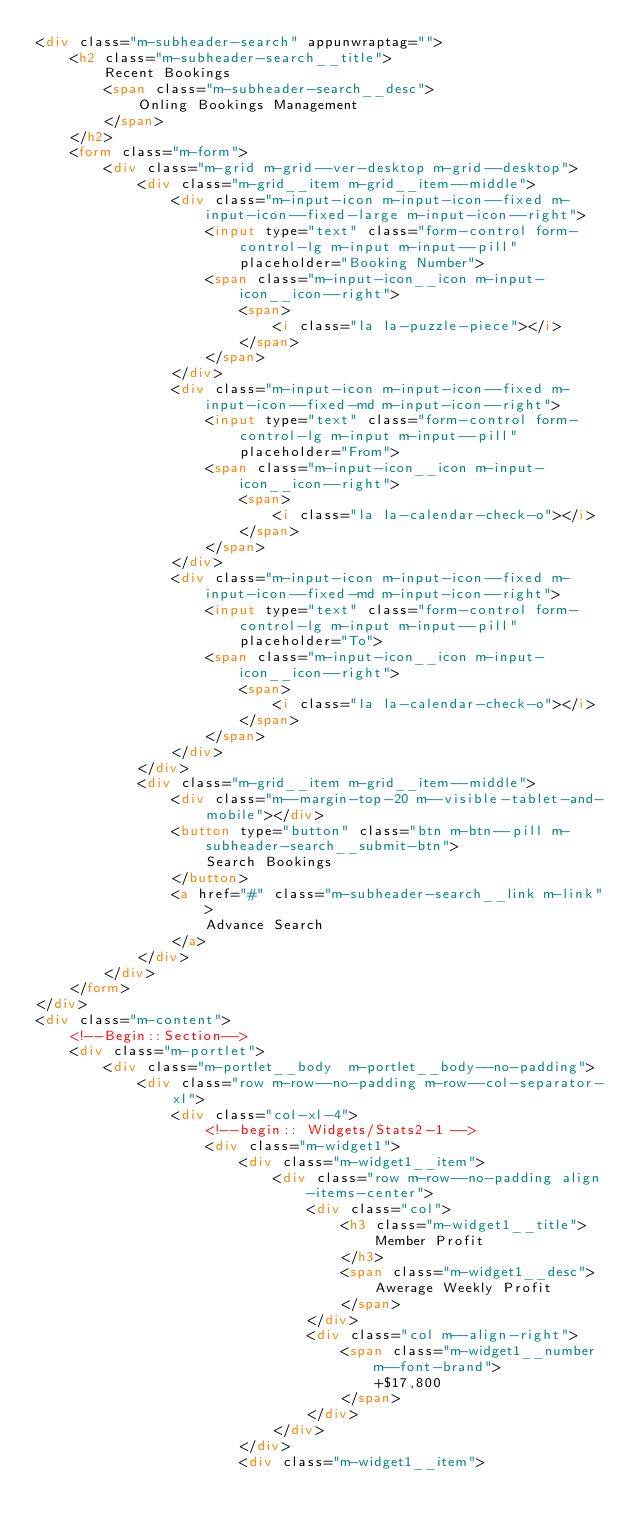Convert code to text. <code><loc_0><loc_0><loc_500><loc_500><_HTML_><div class="m-subheader-search" appunwraptag="">
	<h2 class="m-subheader-search__title">
		Recent Bookings
		<span class="m-subheader-search__desc">
			Onling Bookings Management
		</span>
	</h2>
	<form class="m-form">
		<div class="m-grid m-grid--ver-desktop m-grid--desktop">
			<div class="m-grid__item m-grid__item--middle">
				<div class="m-input-icon m-input-icon--fixed m-input-icon--fixed-large m-input-icon--right">
					<input type="text" class="form-control form-control-lg m-input m-input--pill" placeholder="Booking Number">
					<span class="m-input-icon__icon m-input-icon__icon--right">
						<span>
							<i class="la la-puzzle-piece"></i>
						</span>
					</span>
				</div>
				<div class="m-input-icon m-input-icon--fixed m-input-icon--fixed-md m-input-icon--right">
					<input type="text" class="form-control form-control-lg m-input m-input--pill" placeholder="From">
					<span class="m-input-icon__icon m-input-icon__icon--right">
						<span>
							<i class="la la-calendar-check-o"></i>
						</span>
					</span>
				</div>
				<div class="m-input-icon m-input-icon--fixed m-input-icon--fixed-md m-input-icon--right">
					<input type="text" class="form-control form-control-lg m-input m-input--pill" placeholder="To">
					<span class="m-input-icon__icon m-input-icon__icon--right">
						<span>
							<i class="la la-calendar-check-o"></i>
						</span>
					</span>
				</div>
			</div>
			<div class="m-grid__item m-grid__item--middle">
				<div class="m--margin-top-20 m--visible-tablet-and-mobile"></div>
				<button type="button" class="btn m-btn--pill m-subheader-search__submit-btn">
					Search Bookings
				</button>
				<a href="#" class="m-subheader-search__link m-link">
					Advance Search
				</a>
			</div>
		</div>
	</form>
</div>
<div class="m-content">
	<!--Begin::Section-->
	<div class="m-portlet">
		<div class="m-portlet__body  m-portlet__body--no-padding">
			<div class="row m-row--no-padding m-row--col-separator-xl">
				<div class="col-xl-4">
					<!--begin:: Widgets/Stats2-1 -->
					<div class="m-widget1">
						<div class="m-widget1__item">
							<div class="row m-row--no-padding align-items-center">
								<div class="col">
									<h3 class="m-widget1__title">
										Member Profit
									</h3>
									<span class="m-widget1__desc">
										Awerage Weekly Profit
									</span>
								</div>
								<div class="col m--align-right">
									<span class="m-widget1__number m--font-brand">
										+$17,800
									</span>
								</div>
							</div>
						</div>
						<div class="m-widget1__item"></code> 